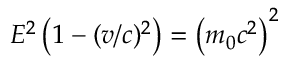Convert formula to latex. <formula><loc_0><loc_0><loc_500><loc_500>E ^ { 2 } \left ( 1 - ( v / c ) ^ { 2 } \right ) = \left ( m _ { 0 } c ^ { 2 } \right ) ^ { 2 }</formula> 